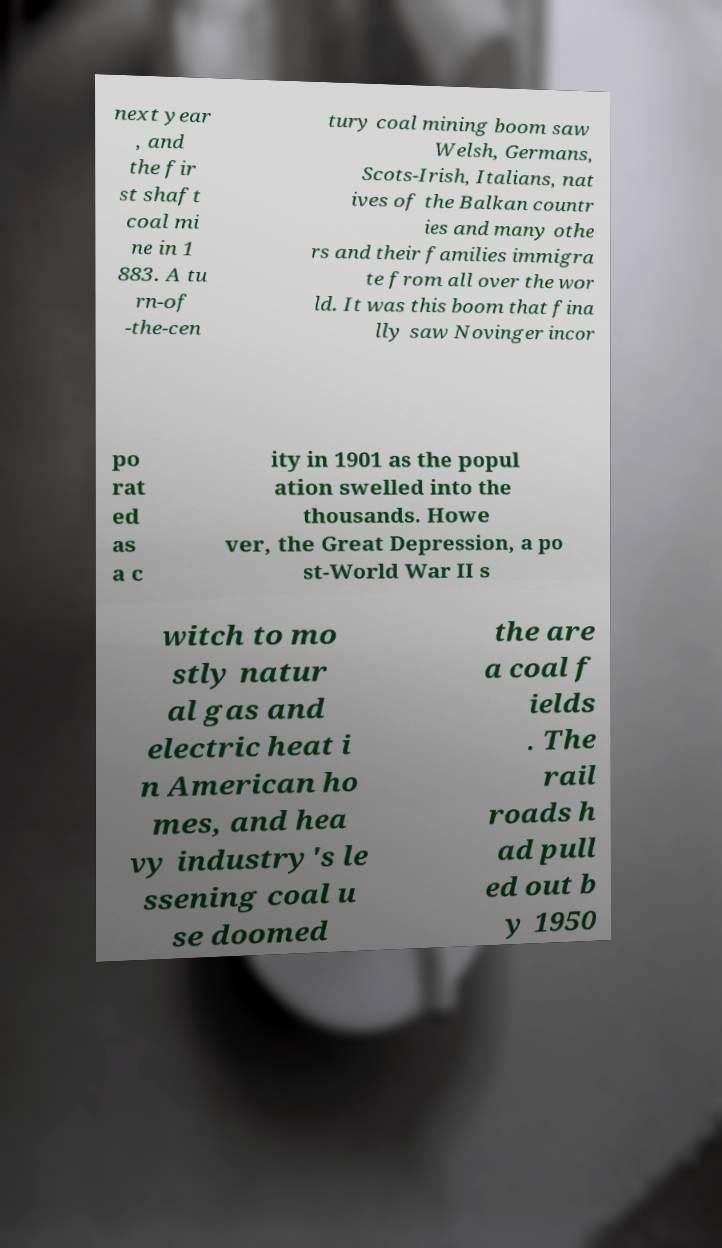For documentation purposes, I need the text within this image transcribed. Could you provide that? next year , and the fir st shaft coal mi ne in 1 883. A tu rn-of -the-cen tury coal mining boom saw Welsh, Germans, Scots-Irish, Italians, nat ives of the Balkan countr ies and many othe rs and their families immigra te from all over the wor ld. It was this boom that fina lly saw Novinger incor po rat ed as a c ity in 1901 as the popul ation swelled into the thousands. Howe ver, the Great Depression, a po st-World War II s witch to mo stly natur al gas and electric heat i n American ho mes, and hea vy industry's le ssening coal u se doomed the are a coal f ields . The rail roads h ad pull ed out b y 1950 